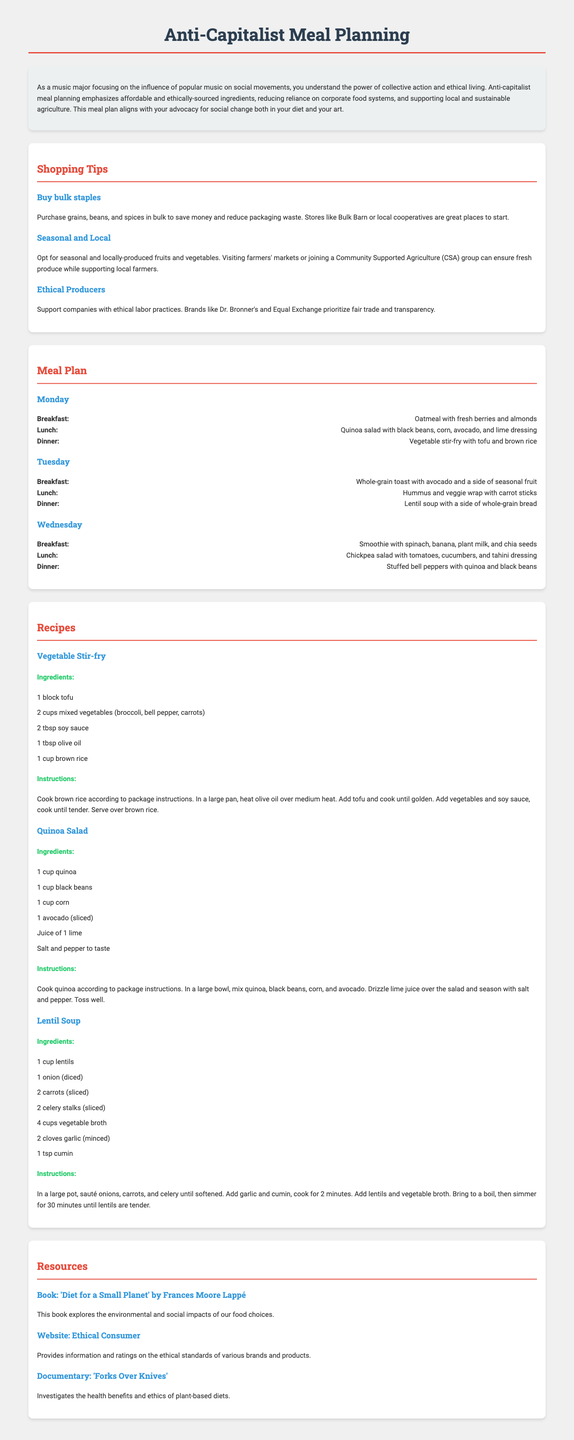What is the title of the document? The title is displayed prominently at the top of the document.
Answer: Anti-Capitalist Meal Planning How many meal days are included in the meal plan? The document lists the meal plan for three days: Monday, Tuesday, and Wednesday.
Answer: 3 What type of meal is suggested for Tuesday's lunch? The document specifies the type of meal for each day, including Tuesday's lunch.
Answer: Hummus and veggie wrap Which ingredient is used in the Vegetable Stir-fry recipe? The Vegetable Stir-fry recipe lists its ingredients clearly, identifying one of them.
Answer: Tofu What cooking method is used for preparing the Lentil Soup? The instructions for the Lentil Soup describe how to prepare it, indicating the method used.
Answer: Sauté What is recommended for purchasing grains and beans? The document provides tips on shopping, including specific recommendations for grains and beans.
Answer: Buy bulk staples What is the main focus of the document? The document is centered around a specific approach to meal planning, which is described in the introduction.
Answer: Anti-capitalist meal planning Name one resource mentioned in the document. The document lists resources that include books, websites, and documentaries.
Answer: 'Diet for a Small Planet' by Frances Moore Lappé 